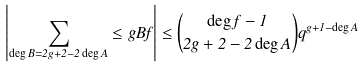Convert formula to latex. <formula><loc_0><loc_0><loc_500><loc_500>\left | \sum _ { \deg B = 2 g + 2 - 2 \deg A } \leq g { B } { f } \right | \leq \binom { \deg f - 1 } { 2 g + 2 - 2 \deg A } q ^ { g + 1 - \deg A }</formula> 